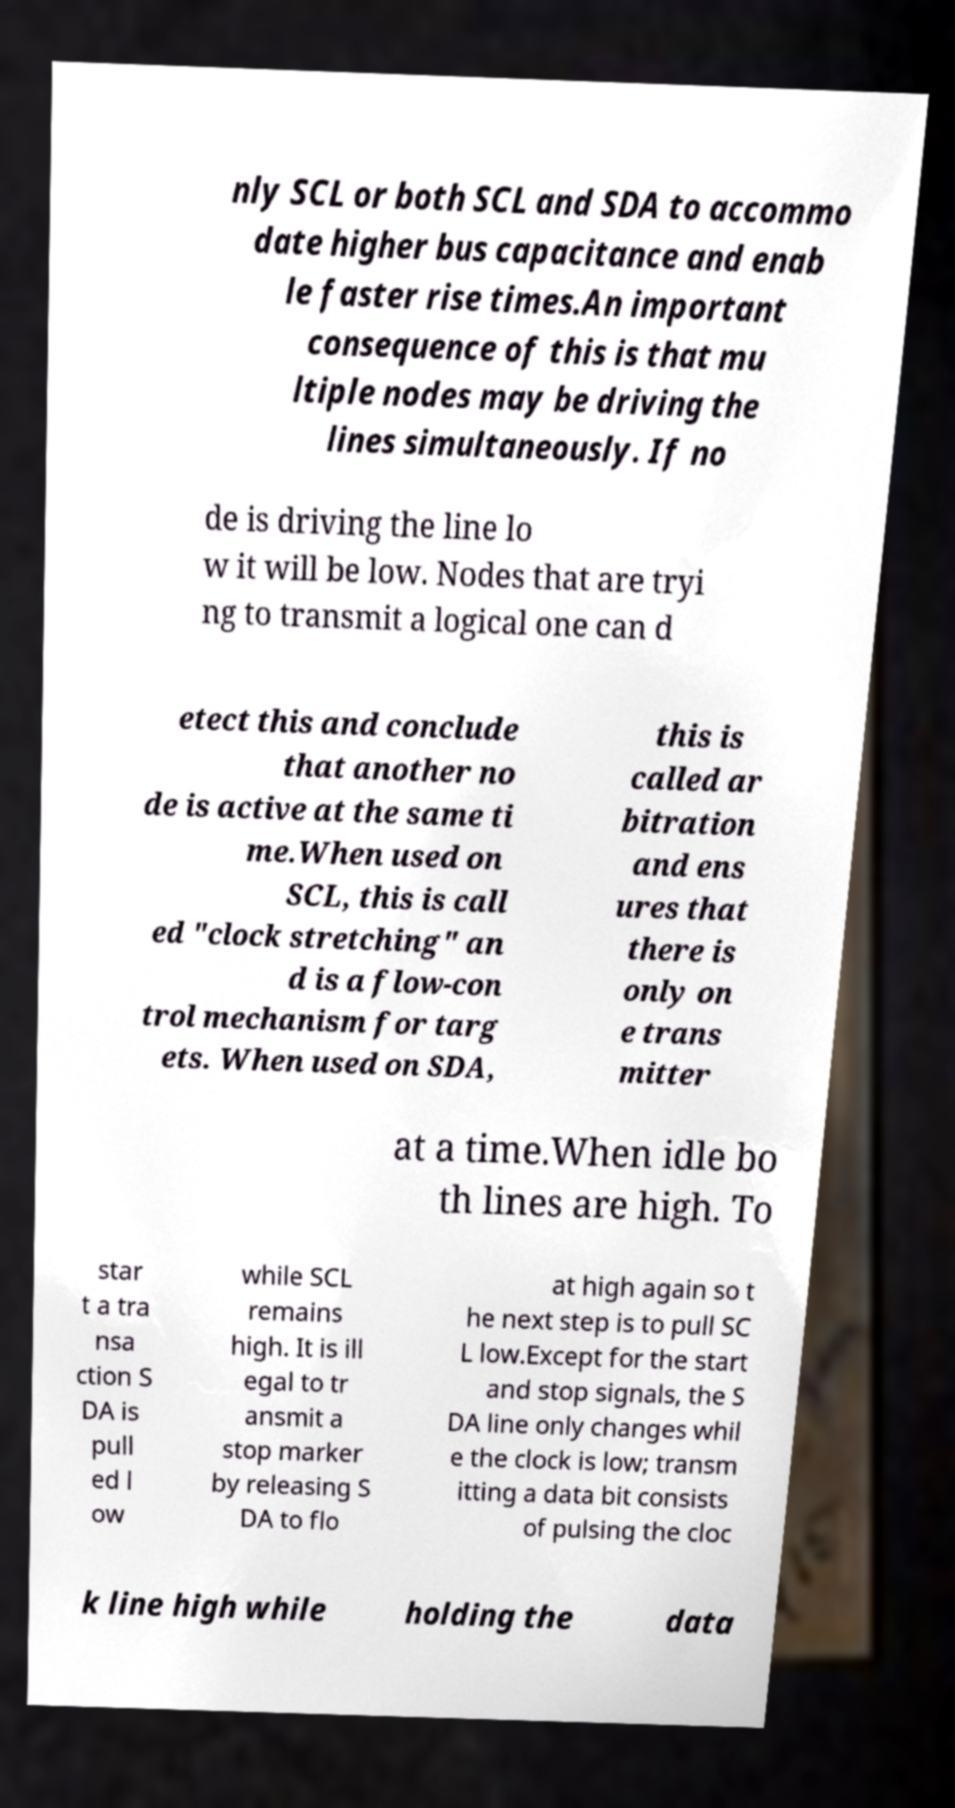There's text embedded in this image that I need extracted. Can you transcribe it verbatim? nly SCL or both SCL and SDA to accommo date higher bus capacitance and enab le faster rise times.An important consequence of this is that mu ltiple nodes may be driving the lines simultaneously. If no de is driving the line lo w it will be low. Nodes that are tryi ng to transmit a logical one can d etect this and conclude that another no de is active at the same ti me.When used on SCL, this is call ed "clock stretching" an d is a flow-con trol mechanism for targ ets. When used on SDA, this is called ar bitration and ens ures that there is only on e trans mitter at a time.When idle bo th lines are high. To star t a tra nsa ction S DA is pull ed l ow while SCL remains high. It is ill egal to tr ansmit a stop marker by releasing S DA to flo at high again so t he next step is to pull SC L low.Except for the start and stop signals, the S DA line only changes whil e the clock is low; transm itting a data bit consists of pulsing the cloc k line high while holding the data 